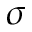<formula> <loc_0><loc_0><loc_500><loc_500>\sigma</formula> 